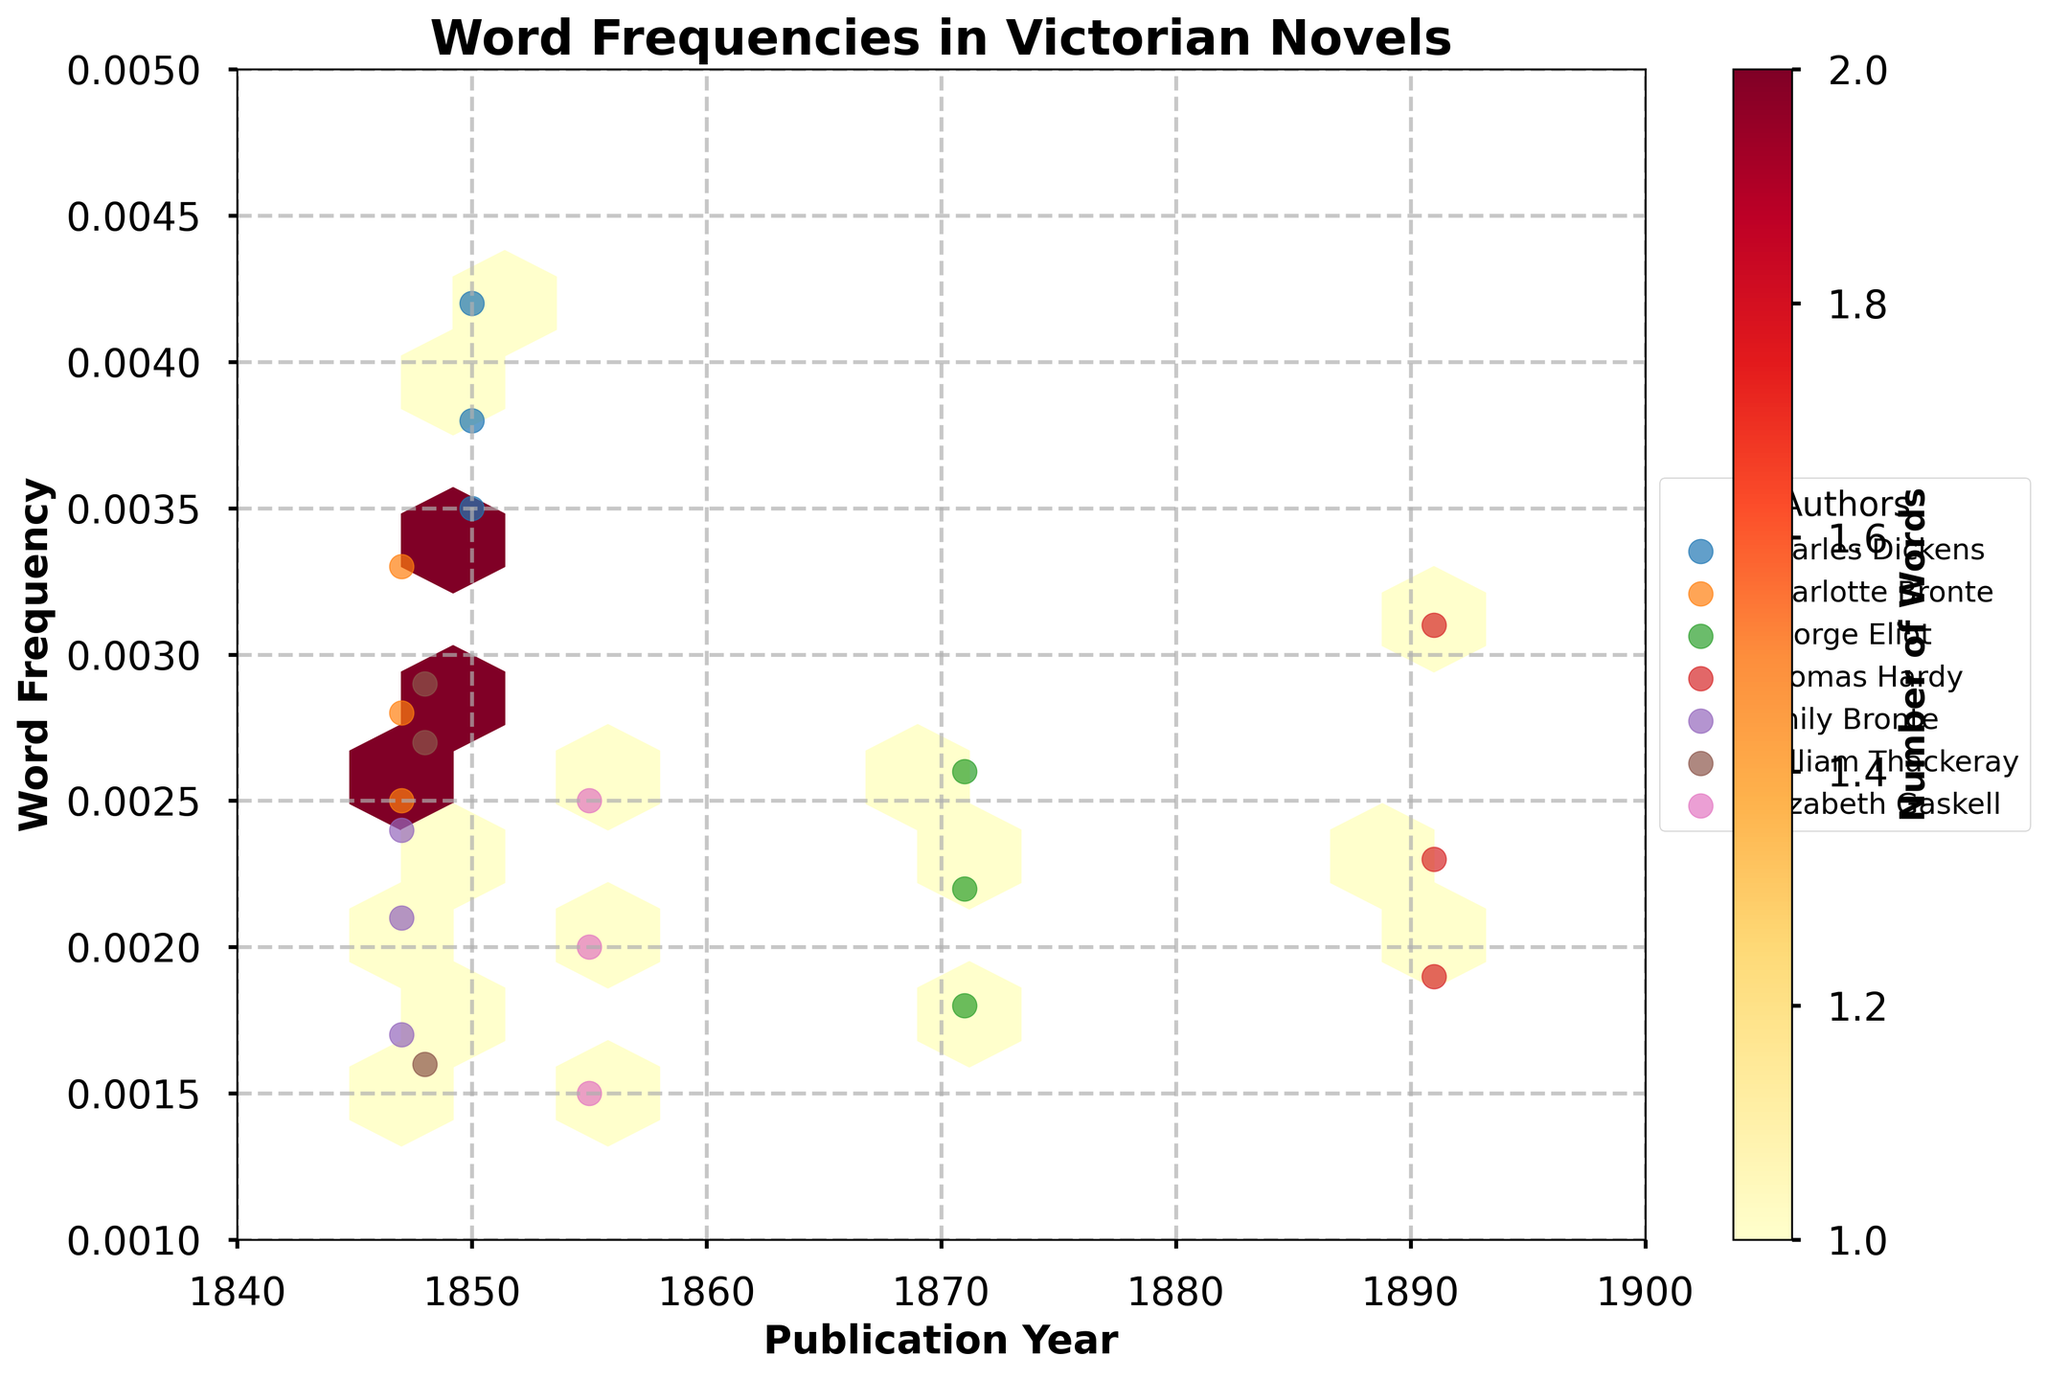What is the title of the plot? The title is located at the top of the plot.
Answer: Word Frequencies in Victorian Novels Which author has the highest word frequency in their works? By examining the scatter points, look for the highest y-value and check its corresponding author in the scatter plot labels.
Answer: Charles Dickens How many years does the plot span? Check the x-axis for the range of publication years.
Answer: 60 years (1840 to 1900) Which year has the highest concentration of word frequencies? Refer to the color intensity in the hexbin plot and identify the year with the densest color.
Answer: 1850 Compare the word frequency clouds of George Eliot and Elizabeth Gaskell. Which one appears more spread out (less dense)? Examine the concentration and spread of the colored hexagons associated with each author's scatter points.
Answer: George Eliot What is the general trend of word frequencies over the years? Observe the overall pattern of the hexbin plot and scatter points to determine if there is an upward or downward trend in y-values over the x-axis.
Answer: No clear trend Of the authors listed, whose words have frequencies closely clustered together? Look for the scatter points representing the authors and see which author's points are closer to each other.
Answer: Charlotte Bronte What is the range of word frequencies depicted in the plot? Refer to the y-axis to see the minimum and maximum values represented.
Answer: 0.001 to 0.005 Which author has the largest number of data points in the plot? Check the scatter plot points labeled with each author's color and count to see who has the most.
Answer: Each author has an equal number of data points How are the hexagons in the plot colored? Look at the colors in the hexbin plot and also the color bar to understand the color intensity representation.
Answer: By the number of words (frequency count) 